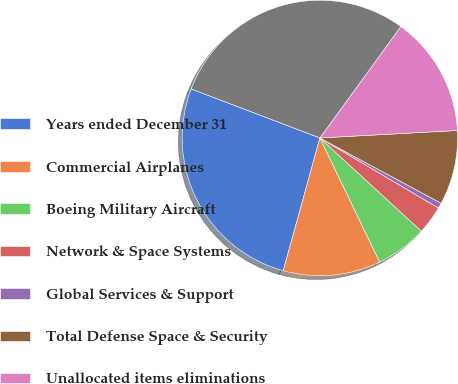<chart> <loc_0><loc_0><loc_500><loc_500><pie_chart><fcel>Years ended December 31<fcel>Commercial Airplanes<fcel>Boeing Military Aircraft<fcel>Network & Space Systems<fcel>Global Services & Support<fcel>Total Defense Space & Security<fcel>Unallocated items eliminations<fcel>Total<nl><fcel>26.5%<fcel>11.43%<fcel>6.03%<fcel>3.33%<fcel>0.63%<fcel>8.73%<fcel>14.14%<fcel>29.2%<nl></chart> 